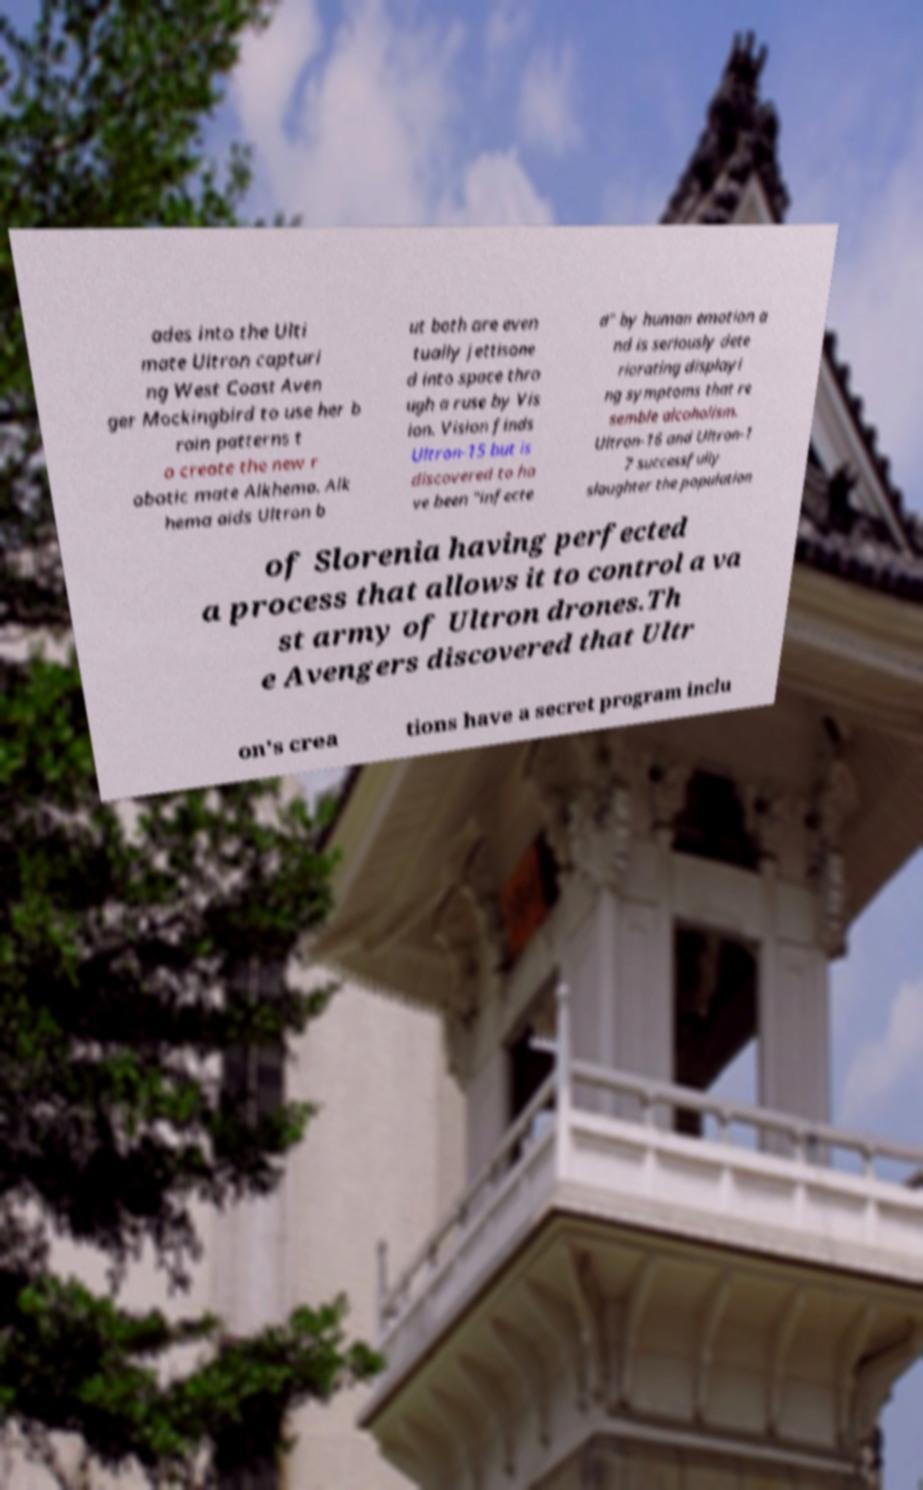What messages or text are displayed in this image? I need them in a readable, typed format. ades into the Ulti mate Ultron capturi ng West Coast Aven ger Mockingbird to use her b rain patterns t o create the new r obotic mate Alkhema. Alk hema aids Ultron b ut both are even tually jettisone d into space thro ugh a ruse by Vis ion. Vision finds Ultron-15 but is discovered to ha ve been "infecte d" by human emotion a nd is seriously dete riorating displayi ng symptoms that re semble alcoholism. Ultron-16 and Ultron-1 7 successfully slaughter the population of Slorenia having perfected a process that allows it to control a va st army of Ultron drones.Th e Avengers discovered that Ultr on's crea tions have a secret program inclu 